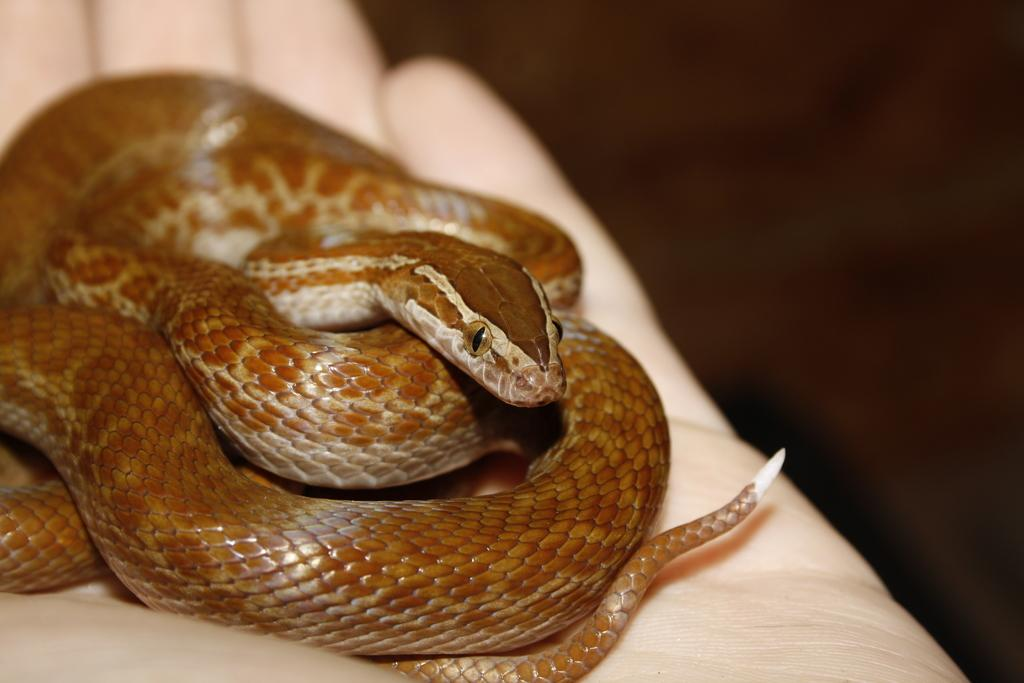What is the color of the cloth in the image? The cloth in the image is white. What type of animal can be seen in the image? There is a snake in the image. Can you see a ghost running a business in the image? There is no ghost or business present in the image. 